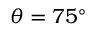<formula> <loc_0><loc_0><loc_500><loc_500>\theta = 7 5 ^ { \circ }</formula> 